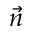<formula> <loc_0><loc_0><loc_500><loc_500>\vec { n }</formula> 